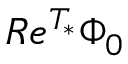<formula> <loc_0><loc_0><loc_500><loc_500>R e ^ { T _ { * } } \Phi _ { 0 }</formula> 